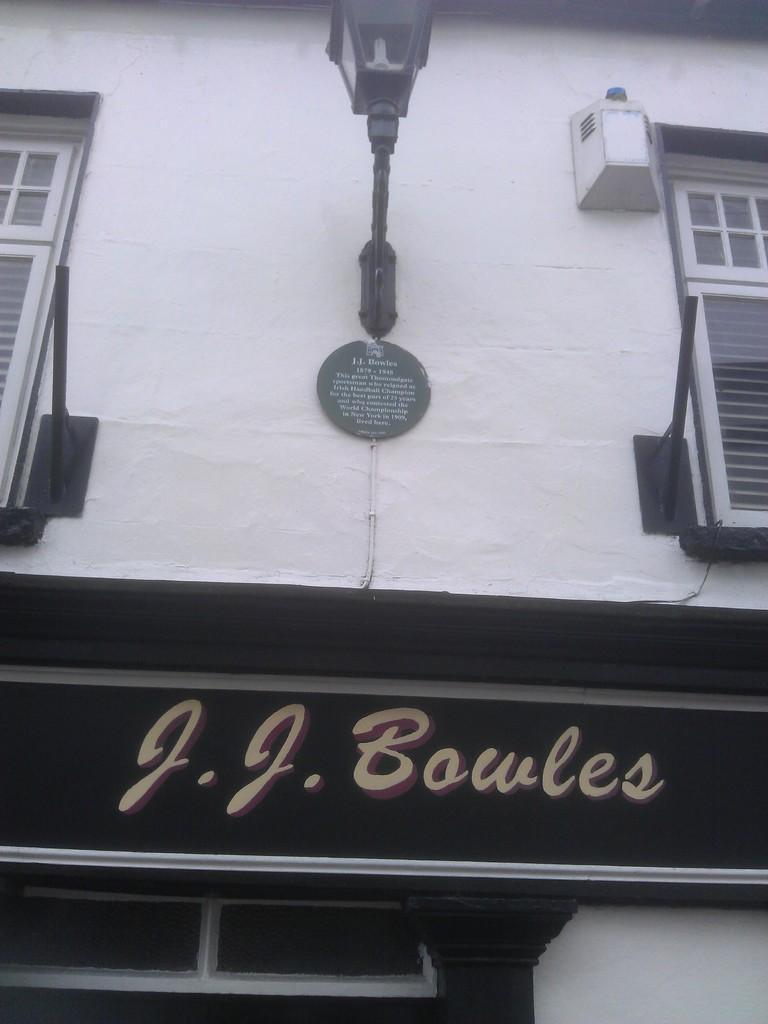Describe this image in one or two sentences. In this image I can see a building in white color, background I can see few lights, windows and I can see black color board. 